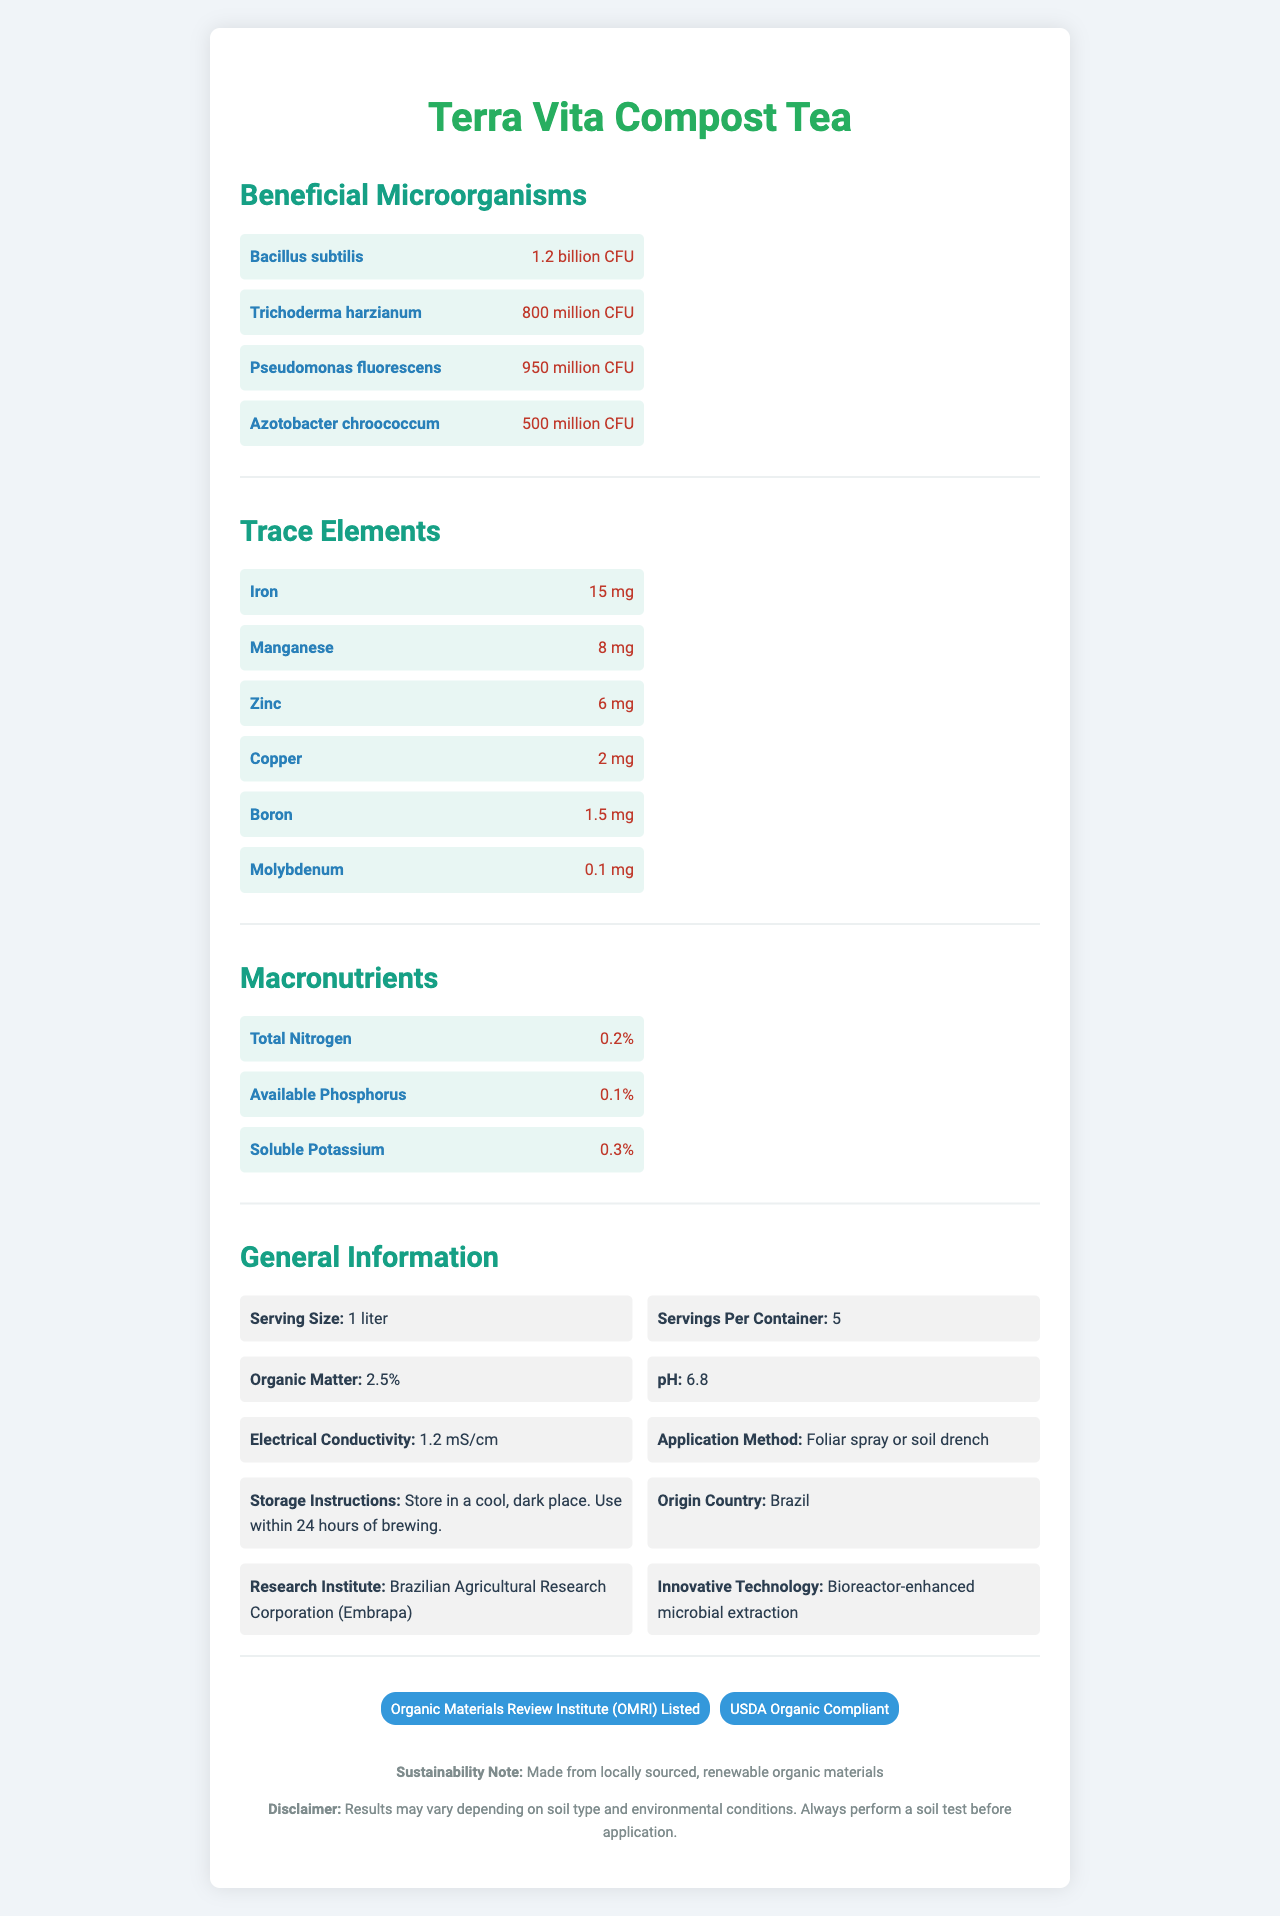what is the serving size of Terra Vita Compost Tea? The serving size is listed under the General Information section of the document as "Serving Size: 1 liter".
Answer: 1 liter how many CFUs of Bacillus subtilis are present in a serving of Terra Vita Compost Tea? This information is mentioned in the Beneficial Microorganisms section specifically for Bacillus subtilis.
Answer: 1.2 billion CFU what is the amount of Iron in a serving of Terra Vita Compost Tea? The amount of Iron is listed in the Trace Elements section as "Iron: 15 mg".
Answer: 15 mg how should Terra Vita Compost Tea be stored? Storage instructions are mentioned in the General Information section: "Storage Instructions: Store in a cool, dark place. Use within 24 hours of brewing."
Answer: Store in a cool, dark place. Use within 24 hours of brewing. what is the pH level of Terra Vita Compost Tea? The pH level is listed under the General Information section as "pH: 6.8".
Answer: 6.8 which microorganism has the lowest count in a serving of Terra Vita Compost Tea?
A. Bacillus subtilis
B. Trichoderma harzianum
C. Pseudomonas fluorescens
D. Azotobacter chroococcum The counts are: Bacillus subtilis (1.2 billion CFU), Trichoderma harzianum (800 million CFU), Pseudomonas fluorescens (950 million CFU), Azotobacter chroococcum (500 million CFU). Azotobacter chroococcum has the lowest count.
Answer: D. Azotobacter chroococcum where is Terra Vita Compost Tea sourced from?
A. United States
B. Brazil
C. Canada
D. India The Origin Country is listed in the General Information section as "Origin Country: Brazil".
Answer: B. Brazil is Terra Vita Compost Tea compliant with USDA Organic standards? It is mentioned under the Certifications section that the product is "USDA Organic Compliant".
Answer: Yes summarize the main characteristics of Terra Vita Compost Tea. The document details various aspects of Terra Vita Compost Tea, including its micro and macronutrient composition, microorganism content, general usage instructions, storage guidelines, and certifications, emphasizing its high quality and sustainability.
Answer: Terra Vita Compost Tea is a microbial-rich agricultural product designed to enhance soil health, containing various beneficial microorganisms and trace elements. It has a serving size of 1 liter with five servings per container. The product includes macronutrients like nitrogen, phosphorus, and potassium, with an overall organic matter content of 2.5%. It is of Brazilian origin, developed using bioreactor-enhanced technology, and is certified by OMRI and USDA Organic standards. It should be stored in a cool, dark place and used within 24 hours of brewing. how many macronutrients are listed in the nutrition facts of Terra Vita Compost Tea? The Macronutrients section lists three macronutrients: Total Nitrogen, Available Phosphorus, and Soluble Potassium.
Answer: 3 which institute conducted the research for Terra Vita Compost Tea? The Research Institute section mentions that the research was conducted by the "Brazilian Agricultural Research Corporation (Embrapa)".
Answer: Brazilian Agricultural Research Corporation (Embrapa) by which method can Terra Vita Compost Tea be applied? The Application Method section states that the product can be applied by "Foliar spray or soil drench".
Answer: Foliar spray or soil drench how many milligrams of zinc are present in a serving of Terra Vita Compost Tea? The amount of Zinc is listed in the Trace Elements section as "Zinc: 6 mg".
Answer: 6 mg how long can Terra Vita Compost Tea be used after brewing? The Storage Instructions state that the product should be used "within 24 hours of brewing".
Answer: 24 hours what is the electrical conductivity value of Terra Vita Compost Tea? This information is found in the General Information section as "Electrical Conductivity: 1.2 mS/cm".
Answer: 1.2 mS/cm what innovative technology is used in the creation of Terra Vita Compost Tea? The Innovative Technology section states that the product uses "Bioreactor-enhanced microbial extraction".
Answer: Bioreactor-enhanced microbial extraction what soil type does Terra Vita Compost Tea work best with? The document contains a disclaimer stating that results may vary depending on soil type and environmental conditions, implying that specific soil types are not mentioned.
Answer: Not enough information 